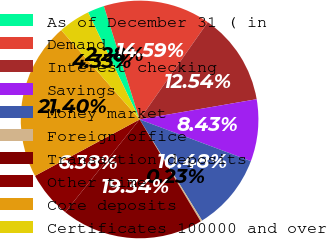<chart> <loc_0><loc_0><loc_500><loc_500><pie_chart><fcel>As of December 31 ( in<fcel>Demand<fcel>Interest checking<fcel>Savings<fcel>Money market<fcel>Foreign office<fcel>Transaction deposits<fcel>Other time<fcel>Core deposits<fcel>Certificates 100000 and over<nl><fcel>2.28%<fcel>14.59%<fcel>12.54%<fcel>8.43%<fcel>10.48%<fcel>0.23%<fcel>19.34%<fcel>6.38%<fcel>21.4%<fcel>4.33%<nl></chart> 